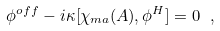Convert formula to latex. <formula><loc_0><loc_0><loc_500><loc_500>\phi ^ { o f f } - i \kappa [ \chi _ { m a } ( A ) , \phi ^ { H } ] = 0 \ ,</formula> 